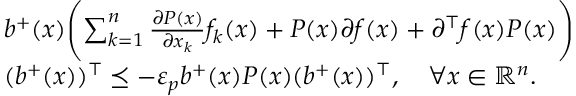Convert formula to latex. <formula><loc_0><loc_0><loc_500><loc_500>\begin{array} { r l } & { b ^ { + } ( x ) \left ( \sum _ { k = 1 } ^ { n } \frac { \partial P ( x ) } { \partial x _ { k } } f _ { k } ( x ) + P ( x ) \partial f ( x ) + \partial ^ { \top } f ( x ) P ( x ) \right ) } \\ & { ( b ^ { + } ( x ) ) ^ { \top } \preceq - \varepsilon _ { p } b ^ { + } ( x ) P ( x ) ( b ^ { + } ( x ) ) ^ { \top } , \quad \forall x \in { \mathbb { R } } ^ { n } . } \end{array}</formula> 